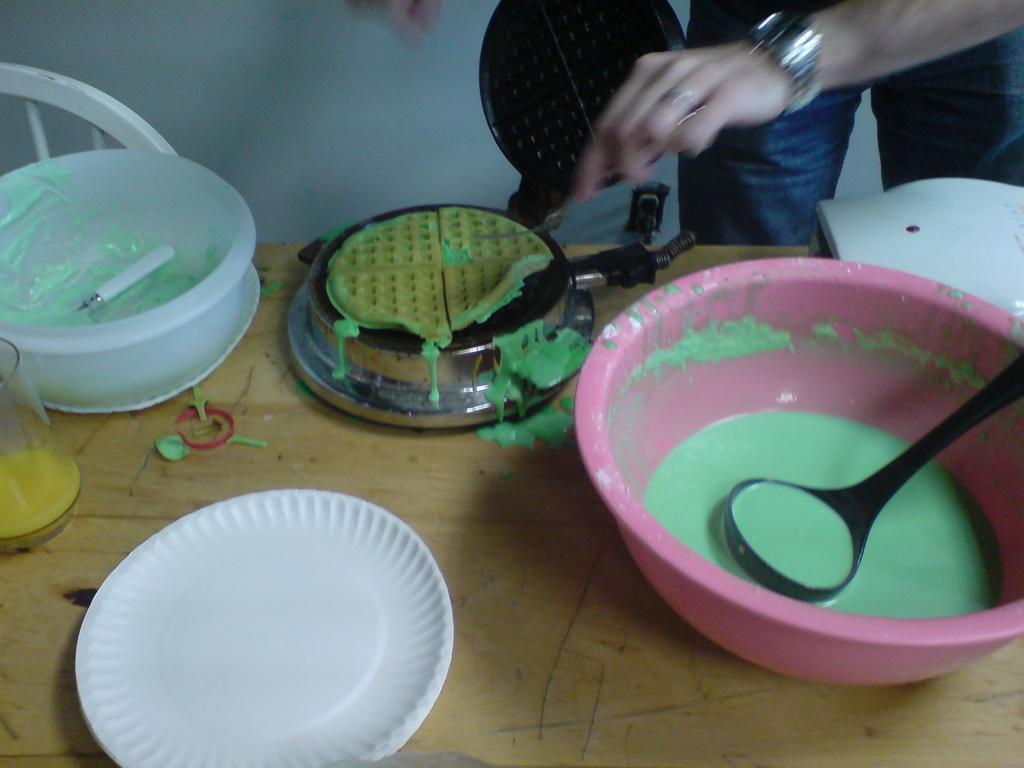In one or two sentences, can you explain what this image depicts? On the background we can see wall. Here we can see partial part of human's hand trying to flip a pancake which is on a pan. Here we can see a glass , plate and a mixture of cream in a bowl with spoon on the table. 